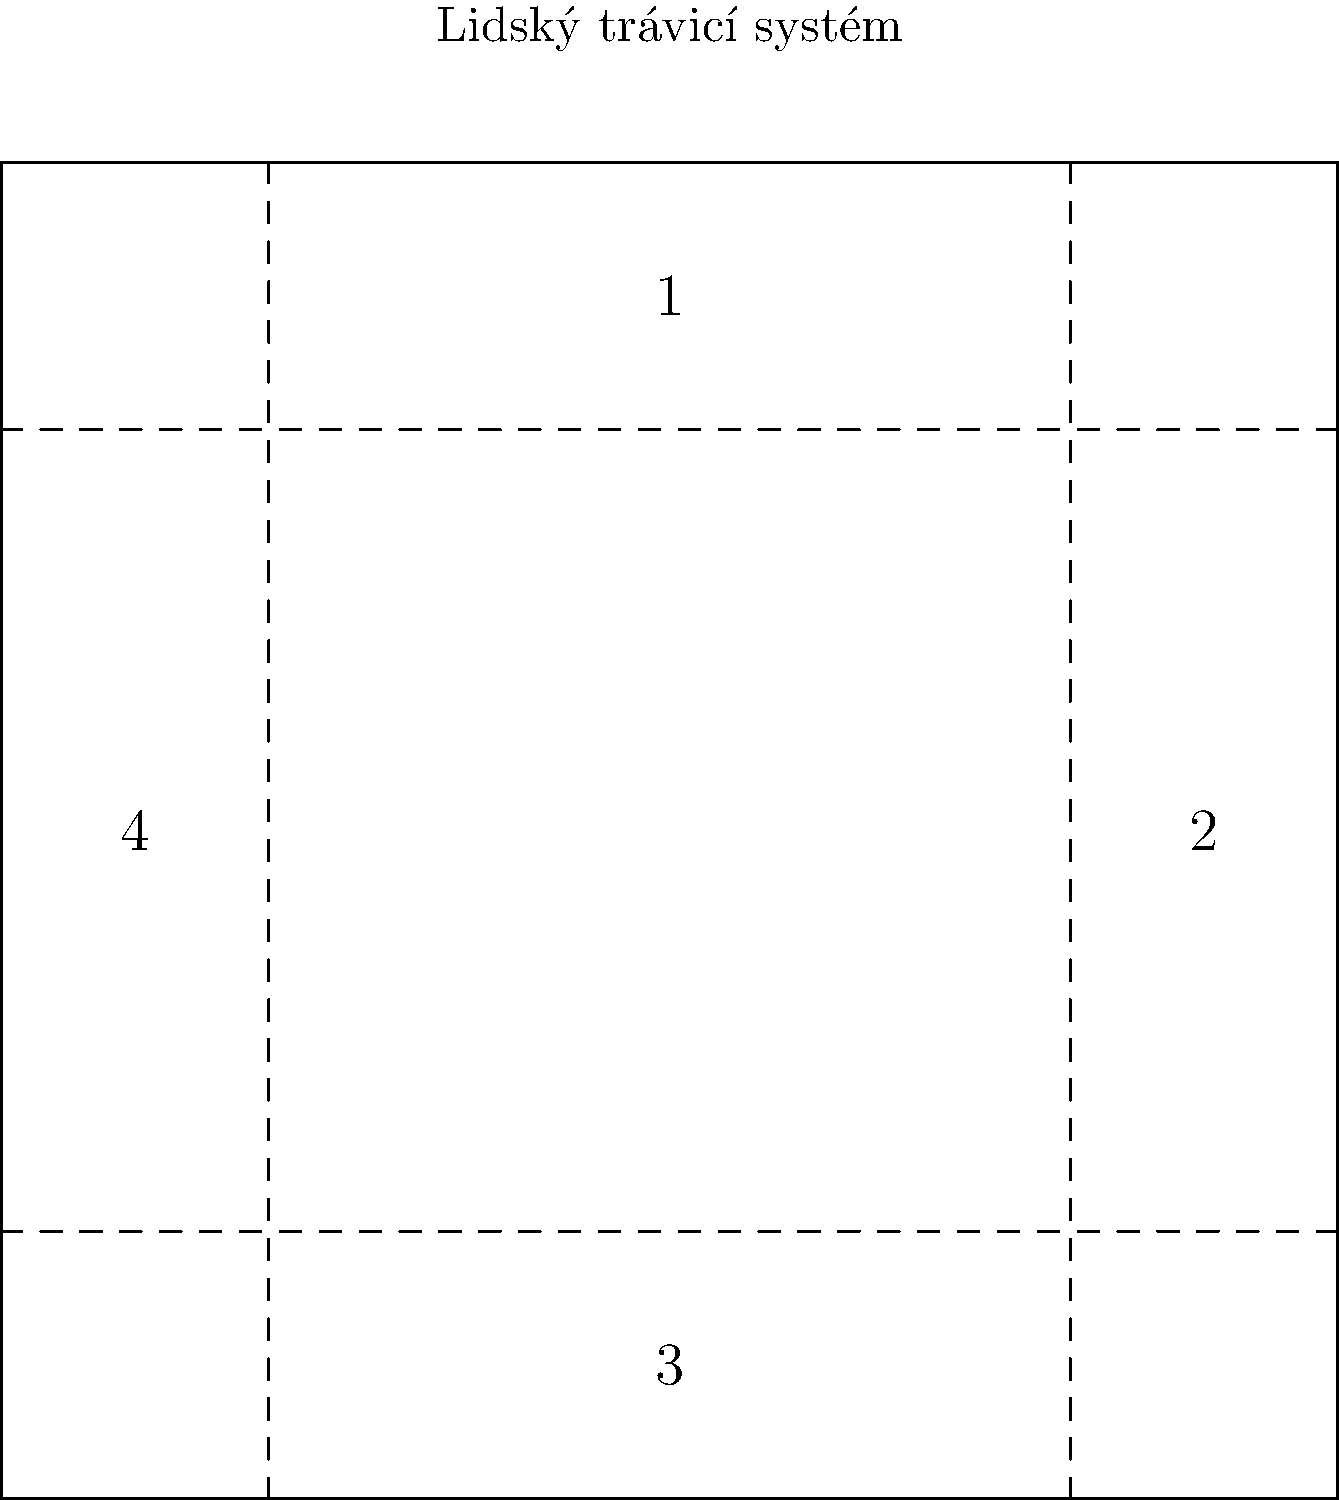Označte hlavní části lidského trávicího systému na obrázku. Která část označená číslem 2 odpovídá orgánu, kde probíhá většina trávení a vstřebávání živin? Abychom správně odpověděli na tuto otázku, pojďme si projít hlavní části lidského trávicího systému:

1. Část označená číslem 1 představuje horní část trávicího traktu, což zahrnuje ústa, hltan a jícen.
2. Část označená číslem 2 je střední část trávicího systému, která zahrnuje žaludek a tenké střevo.
3. Část označená číslem 3 představuje dolní část trávicího traktu, což je tlusté střevo.
4. Část označená číslem 4 symbolizuje játra a slinivku břišní, které jsou důležitými přídatnými orgány trávicího systému.

Většina trávení a vstřebávání živin probíhá v tenkém střevě, které je součástí části označené číslem 2. Tenké střevo má tři části: dvanáctník, lačník a kyčelník. Jeho celková délka je asi 6-7 metrů a má velkou plochu díky klkům a mikroklkům, což umožňuje efektivní vstřebávání živin.

V tenkém střevě dochází k:
1. Dokončení trávení bílkovin, tuků a sacharidů
2. Vstřebávání většiny živin, vitamínů a minerálů
3. Sekreci trávicích enzymů a hormonů

Proto je tenké střevo, které je součástí části označené číslem 2, odpovědí na tuto otázku.
Answer: Tenké střevo 